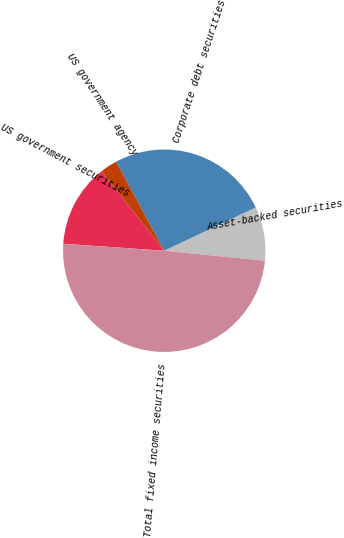<chart> <loc_0><loc_0><loc_500><loc_500><pie_chart><fcel>Asset-backed securities<fcel>Corporate debt securities<fcel>US government agency<fcel>US government securities<fcel>Total fixed income securities<nl><fcel>8.61%<fcel>25.86%<fcel>2.73%<fcel>13.28%<fcel>49.52%<nl></chart> 